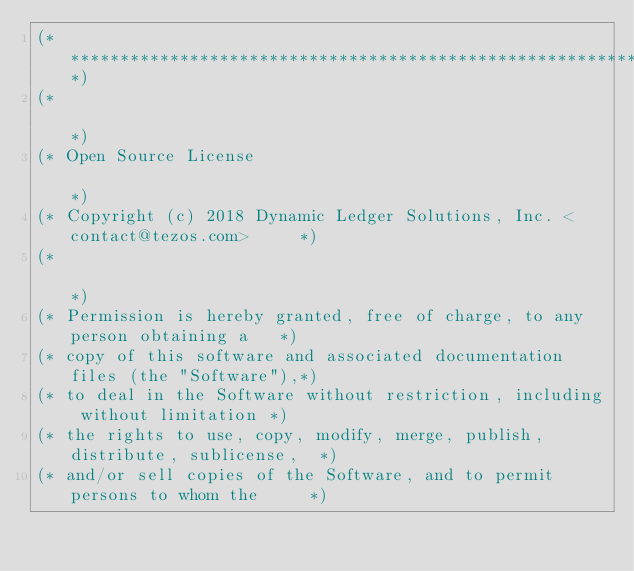<code> <loc_0><loc_0><loc_500><loc_500><_OCaml_>(*****************************************************************************)
(*                                                                           *)
(* Open Source License                                                       *)
(* Copyright (c) 2018 Dynamic Ledger Solutions, Inc. <contact@tezos.com>     *)
(*                                                                           *)
(* Permission is hereby granted, free of charge, to any person obtaining a   *)
(* copy of this software and associated documentation files (the "Software"),*)
(* to deal in the Software without restriction, including without limitation *)
(* the rights to use, copy, modify, merge, publish, distribute, sublicense,  *)
(* and/or sell copies of the Software, and to permit persons to whom the     *)</code> 